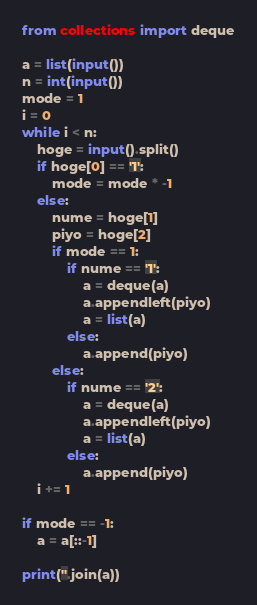Convert code to text. <code><loc_0><loc_0><loc_500><loc_500><_Python_>from collections import deque

a = list(input())
n = int(input())
mode = 1
i = 0
while i < n:
    hoge = input().split()
    if hoge[0] == '1':
        mode = mode * -1
    else:
        nume = hoge[1]
        piyo = hoge[2]
        if mode == 1:
            if nume == '1':
                a = deque(a)
                a.appendleft(piyo)
                a = list(a)
            else:
                a.append(piyo)
        else:
            if nume == '2':
                a = deque(a)
                a.appendleft(piyo)
                a = list(a)
            else:
                a.append(piyo)
    i += 1

if mode == -1:
    a = a[::-1]

print(''.join(a))
</code> 